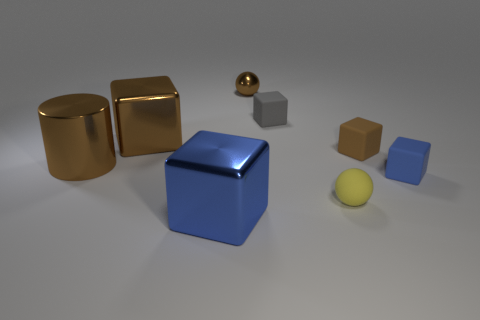Subtract all tiny gray matte blocks. How many blocks are left? 4 Subtract all red cylinders. How many blue cubes are left? 2 Add 1 big gray shiny cylinders. How many objects exist? 9 Subtract 1 balls. How many balls are left? 1 Subtract all blue cubes. How many cubes are left? 3 Add 2 brown balls. How many brown balls are left? 3 Add 5 small red shiny blocks. How many small red shiny blocks exist? 5 Subtract 0 yellow cylinders. How many objects are left? 8 Subtract all cylinders. How many objects are left? 7 Subtract all purple cylinders. Subtract all gray balls. How many cylinders are left? 1 